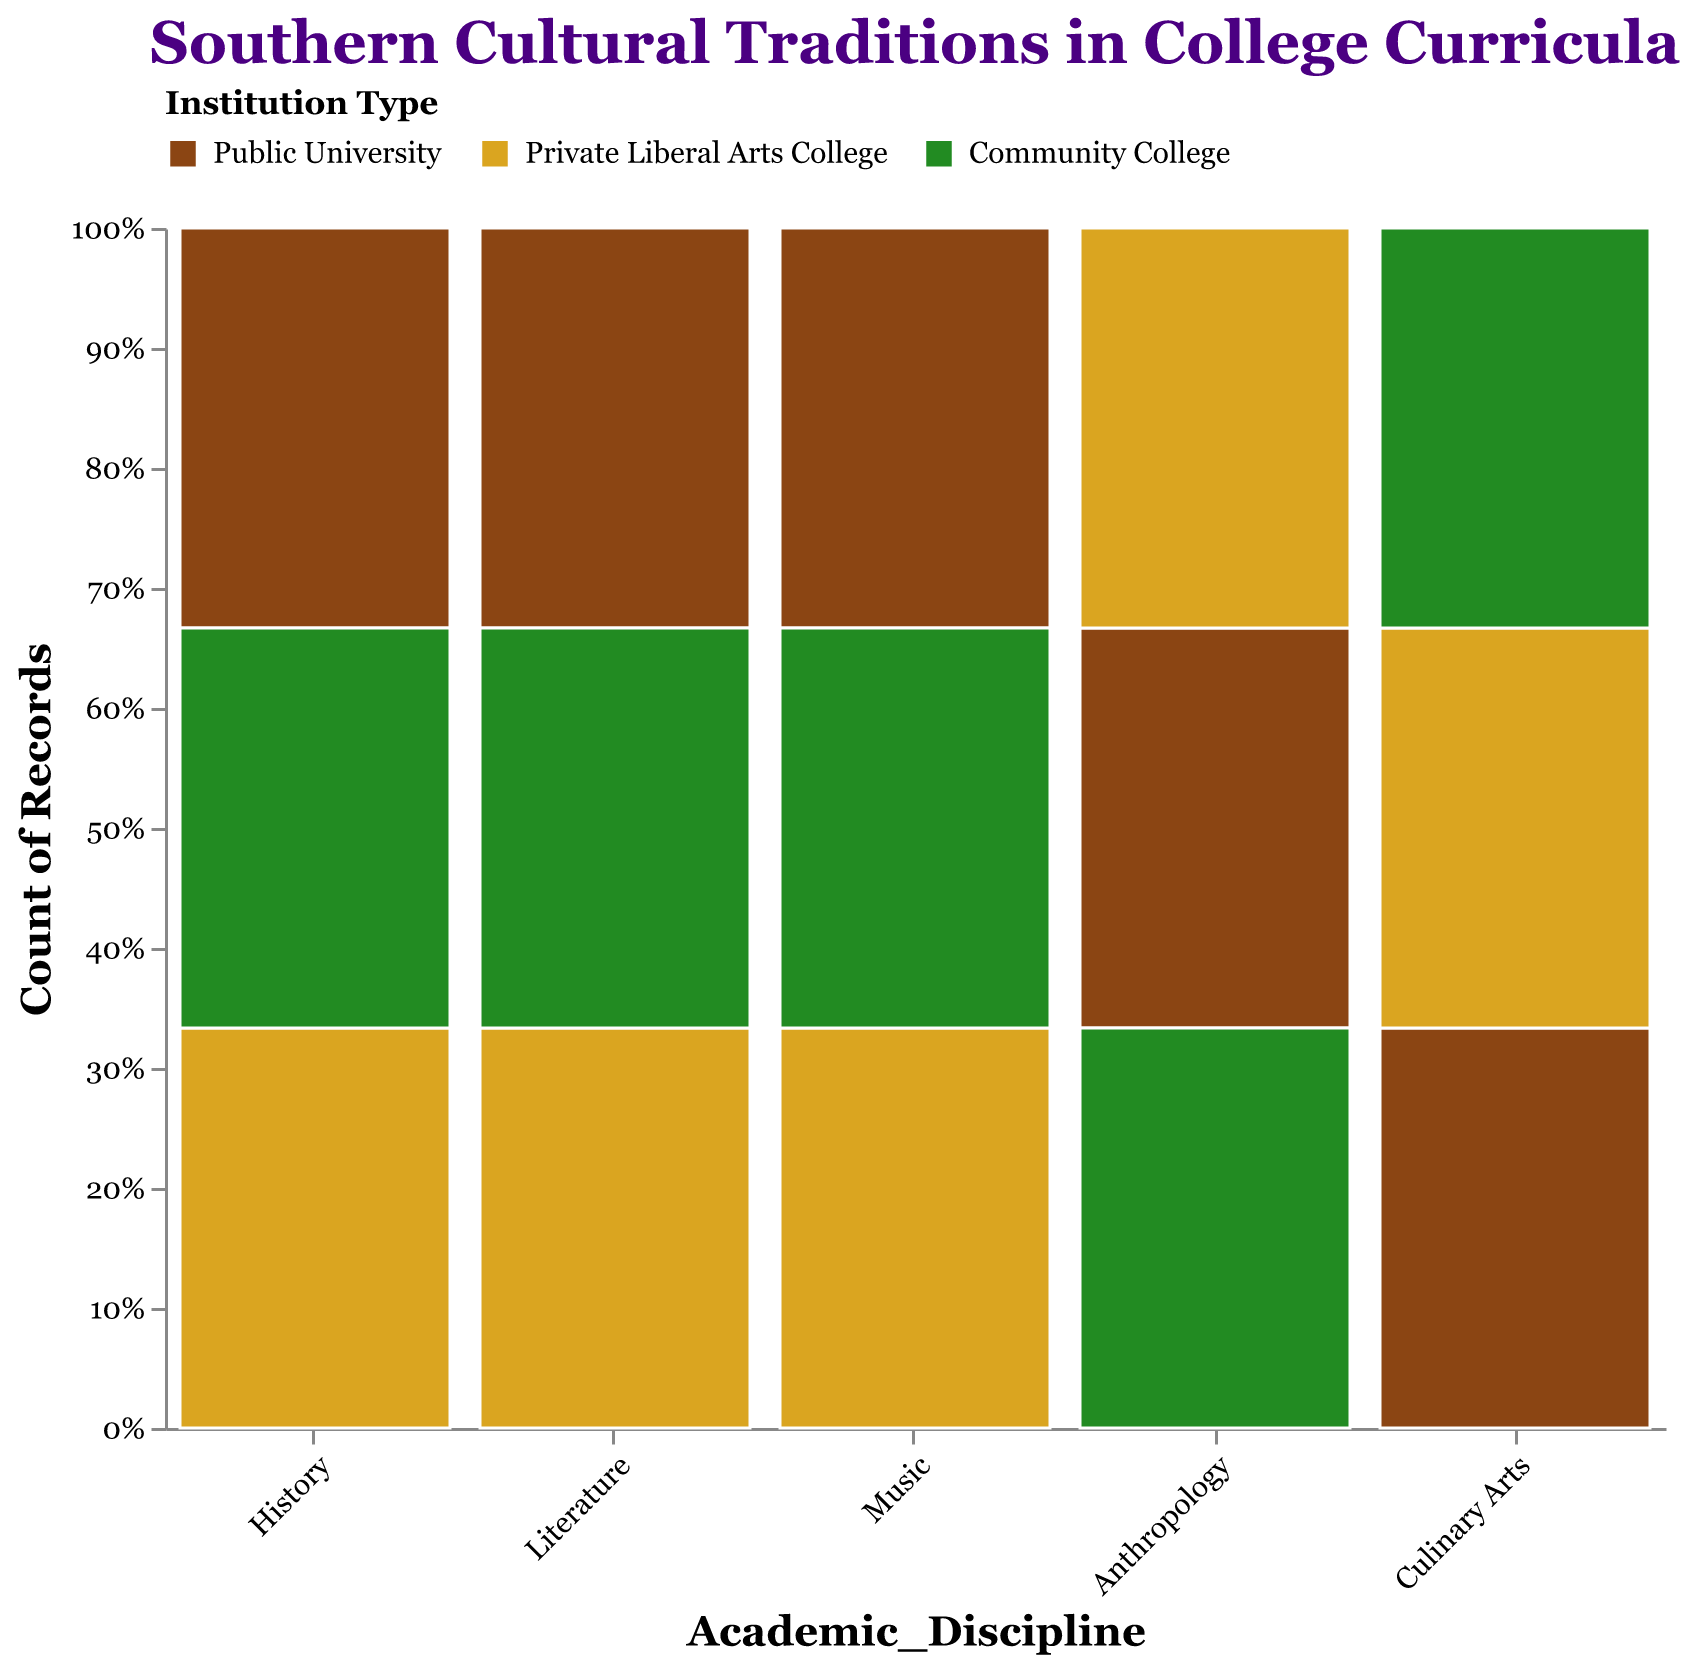What is the most represented cultural tradition in the "Public University" category? By looking at the bars in the "Public University" section, we can see that "Civil War Reenactments," "Southern Gothic," and "Blues and Jazz" have "High" representation, but "Blues and Jazz" is the tallest bar, indicating it is the most represented tradition within "Public University."
Answer: Blues and Jazz Which institution type has the least representation for the "Gullah Geechee Traditions"? Gullah Geechee Traditions appears in the "Community College" category with a "Very Low" representation, making it the least represented in that institution type.
Answer: Community College How many cultural traditions are represented at a "Public University"? Counting the bars under "Public University" across all academic disciplines, we can see that there are five cultural traditions represented: "Civil War Reenactments," "Southern Gothic," "Blues and Jazz," "Native American Heritage," and "Soul Food."
Answer: 5 Among the "History" disciplines, which institution has the highest representation? In the "History" discipline, the bar representing "Civil War Reenactments" under "Public University" has a "High" representation, which is the highest among the other institution types.
Answer: Public University Compare the representation of "Barbecue Traditions" across different institution types. Which institution type has the highest representation? "Barbecue Traditions" is represented under "Community College" with a "High" representation. This is higher compared to "Soul Food" at "Public University" and "Cajun Cuisine" at "Private Liberal Arts College," which have "Medium" and "Low" representation, respectively.
Answer: Community College What is the overall representation trend for "Anthropology" across all institution types? Observing the "Anthropology" bars across the institution types, "Native American Heritage" at "Public University" shows "Medium" representation, "Creole Culture" at "Private Liberal Arts College" shows "Low" representation, and "Gullah Geechee Traditions" at "Community College" has "Very Low" representation. This indicates a declining trend from "Medium" to "Very Low."
Answer: Declining trend In which academic discipline is "Antebellum Architecture" represented, and what is its representation level? "Antebellum Architecture" appears under the "History" category and is represented at a "Medium" level at "Private Liberal Arts College."
Answer: History, Medium How does the representation of "African American Folklore" at community colleges compare to the representation of "Appalachian Storytelling" at private liberal arts colleges? "African American Folklore" at community colleges has a "Low" representation, while "Appalachian Storytelling" at private liberal arts colleges has a "Medium" representation. "Appalachian Storytelling" has a higher representation compared to "African American Folklore."
Answer: Medium higher than Low Is there a difference in the representation levels of "Bluegrass" in "Private Liberal Arts College" compared to "Gospel" in "Community College"? "Bluegrass" at "Private Liberal Arts College" has a "Medium" representation, while "Gospel" at "Community College" has a "Low" representation, indicating that "Bluegrass" has a higher representation level.
Answer: Yes, Bluegrass higher Which academic discipline at "Private Liberal Arts College" has the highest representation, and what tradition does it involve? At "Private Liberal Arts College," "Antebellum Architecture" in the "History" discipline has the highest representation with a "Medium" level.
Answer: History, Antebellum Architecture 